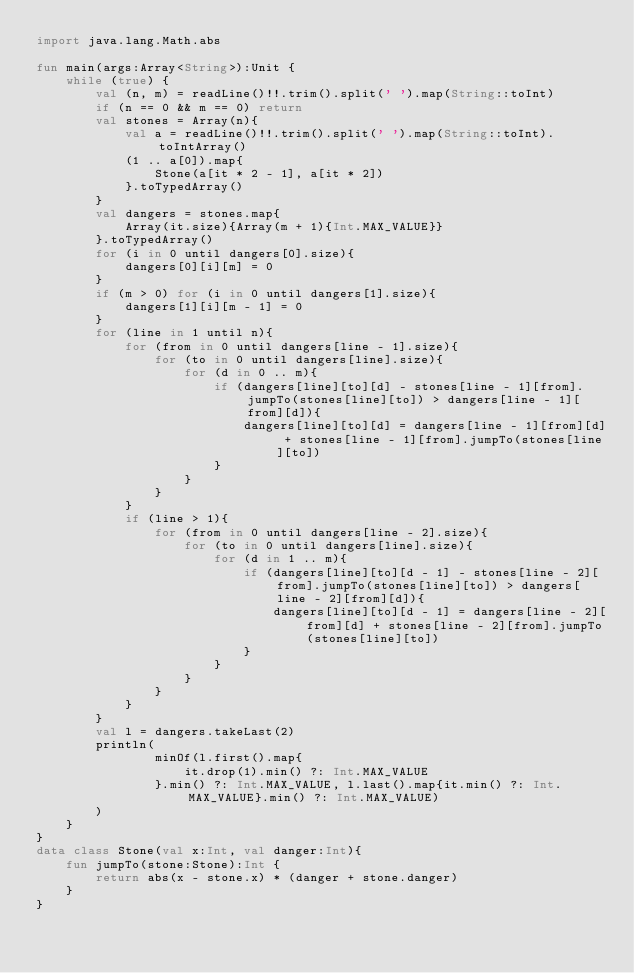<code> <loc_0><loc_0><loc_500><loc_500><_Kotlin_>import java.lang.Math.abs

fun main(args:Array<String>):Unit {
    while (true) {
        val (n, m) = readLine()!!.trim().split(' ').map(String::toInt)
        if (n == 0 && m == 0) return
        val stones = Array(n){
            val a = readLine()!!.trim().split(' ').map(String::toInt).toIntArray()
            (1 .. a[0]).map{
                Stone(a[it * 2 - 1], a[it * 2])
            }.toTypedArray()
        }
        val dangers = stones.map{
            Array(it.size){Array(m + 1){Int.MAX_VALUE}}
        }.toTypedArray()
        for (i in 0 until dangers[0].size){
            dangers[0][i][m] = 0
        }
        if (m > 0) for (i in 0 until dangers[1].size){
            dangers[1][i][m - 1] = 0
        }
        for (line in 1 until n){
            for (from in 0 until dangers[line - 1].size){
                for (to in 0 until dangers[line].size){
                    for (d in 0 .. m){
                        if (dangers[line][to][d] - stones[line - 1][from].jumpTo(stones[line][to]) > dangers[line - 1][from][d]){
                            dangers[line][to][d] = dangers[line - 1][from][d] + stones[line - 1][from].jumpTo(stones[line][to])
                        }
                    }
                }
            }
            if (line > 1){
                for (from in 0 until dangers[line - 2].size){
                    for (to in 0 until dangers[line].size){
                        for (d in 1 .. m){
                            if (dangers[line][to][d - 1] - stones[line - 2][from].jumpTo(stones[line][to]) > dangers[line - 2][from][d]){
                                dangers[line][to][d - 1] = dangers[line - 2][from][d] + stones[line - 2][from].jumpTo(stones[line][to])
                            }
                        }
                    }
                }
            }
        }
        val l = dangers.takeLast(2)
        println(
                minOf(l.first().map{
                    it.drop(1).min() ?: Int.MAX_VALUE
                }.min() ?: Int.MAX_VALUE, l.last().map{it.min() ?: Int.MAX_VALUE}.min() ?: Int.MAX_VALUE)
        )
    }
}
data class Stone(val x:Int, val danger:Int){
    fun jumpTo(stone:Stone):Int {
        return abs(x - stone.x) * (danger + stone.danger)
    }
}
</code> 